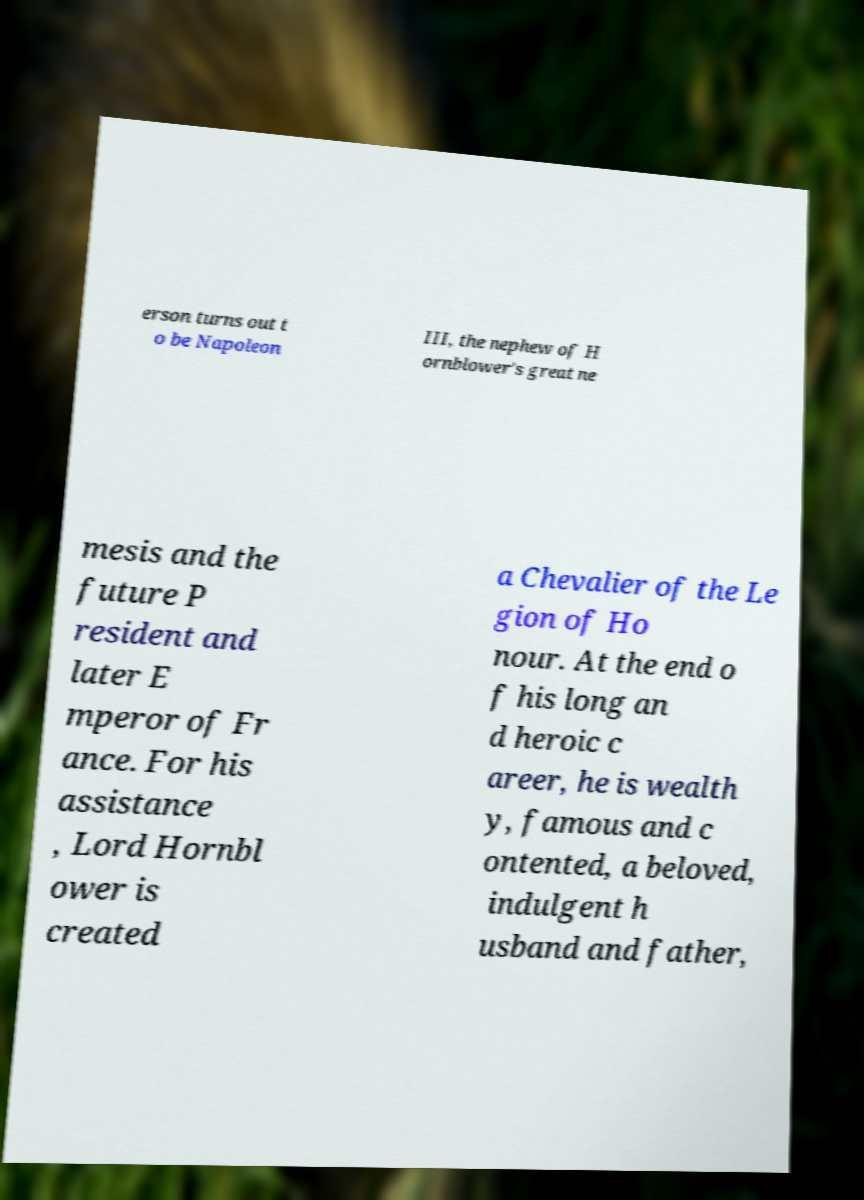Can you accurately transcribe the text from the provided image for me? erson turns out t o be Napoleon III, the nephew of H ornblower's great ne mesis and the future P resident and later E mperor of Fr ance. For his assistance , Lord Hornbl ower is created a Chevalier of the Le gion of Ho nour. At the end o f his long an d heroic c areer, he is wealth y, famous and c ontented, a beloved, indulgent h usband and father, 